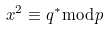<formula> <loc_0><loc_0><loc_500><loc_500>x ^ { 2 } \equiv q ^ { * } { \bmod { p } }</formula> 